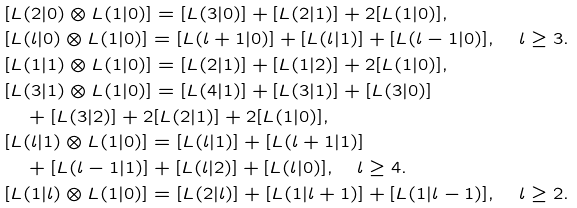Convert formula to latex. <formula><loc_0><loc_0><loc_500><loc_500>& [ L ( 2 | 0 ) \otimes L ( 1 | 0 ) ] = [ L ( 3 | 0 ) ] + [ L ( 2 | 1 ) ] + 2 [ L ( 1 | 0 ) ] , \\ & [ L ( l | 0 ) \otimes L ( 1 | 0 ) ] = [ L ( l + 1 | 0 ) ] + [ L ( l | 1 ) ] + [ L ( l - 1 | 0 ) ] , \quad l \geq 3 . \\ & [ L ( 1 | 1 ) \otimes L ( 1 | 0 ) ] = [ L ( 2 | 1 ) ] + [ L ( 1 | 2 ) ] + 2 [ L ( 1 | 0 ) ] , \\ & [ L ( 3 | 1 ) \otimes L ( 1 | 0 ) ] = [ L ( 4 | 1 ) ] + [ L ( 3 | 1 ) ] + [ L ( 3 | 0 ) ] \\ & \quad + [ L ( 3 | 2 ) ] + 2 [ L ( 2 | 1 ) ] + 2 [ L ( 1 | 0 ) ] , \\ & [ L ( l | 1 ) \otimes L ( 1 | 0 ) ] = [ L ( l | 1 ) ] + [ L ( l + 1 | 1 ) ] \\ & \quad + [ L ( l - 1 | 1 ) ] + [ L ( l | 2 ) ] + [ L ( l | 0 ) ] , \quad l \geq 4 . \\ & [ L ( 1 | l ) \otimes L ( 1 | 0 ) ] = [ L ( 2 | l ) ] + [ L ( 1 | l + 1 ) ] + [ L ( 1 | l - 1 ) ] , \quad l \geq 2 .</formula> 